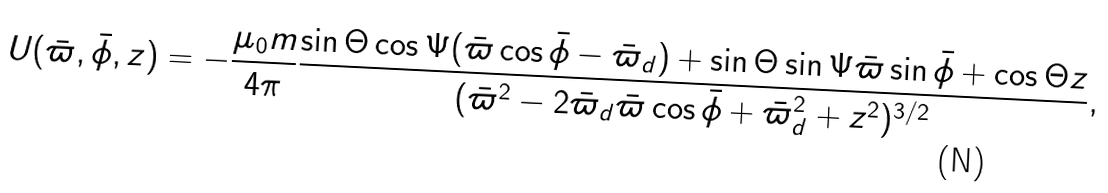Convert formula to latex. <formula><loc_0><loc_0><loc_500><loc_500>U ( \bar { \varpi } , \bar { \phi } , z ) = - \frac { \mu _ { 0 } m } { 4 \pi } \frac { \sin \Theta \cos \Psi ( \bar { \varpi } \cos \bar { \phi } - \bar { \varpi } _ { d } ) + \sin \Theta \sin \Psi \bar { \varpi } \sin \bar { \phi } + \cos \Theta z } { ( \bar { \varpi } ^ { 2 } - 2 \bar { \varpi } _ { d } \bar { \varpi } \cos \bar { \phi } + \bar { \varpi } _ { d } ^ { 2 } + z ^ { 2 } ) ^ { 3 / 2 } } ,</formula> 